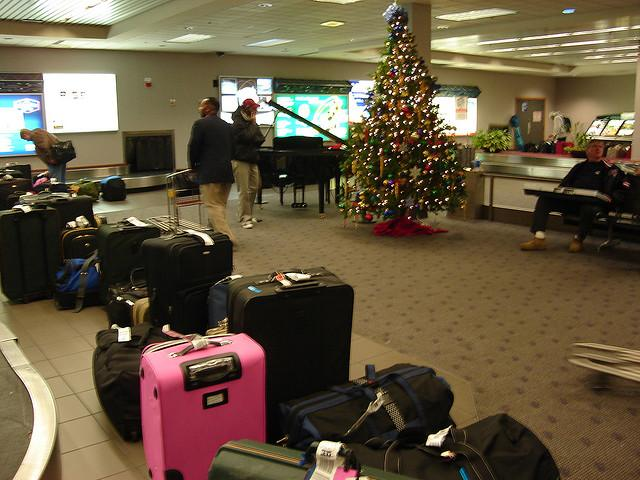A baggage carousel is a device generally at where? Please explain your reasoning. airport. People bring luggage while traveling from one place to another. 